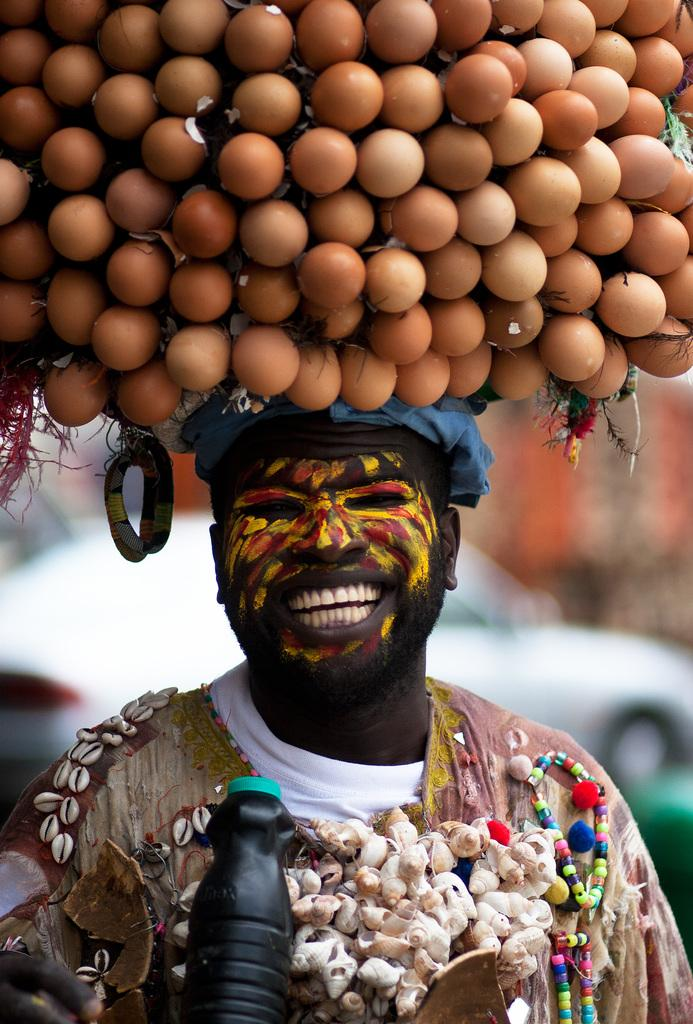What is the main subject of the image? There is a person standing in the middle of the image. What is the person holding in the image? The person is holding some products. What is the person's facial expression in the image? The person is smiling. What can be seen behind the person in the image? There is a vehicle visible behind the person. What type of coat is the person wearing in the image? There is no coat visible in the image; the person is not wearing one. Can you see any landmarks or geographical features in the image? The image does not show any landmarks or geographical features; it only shows a person, some products, a smiling face, and a vehicle in the background. 